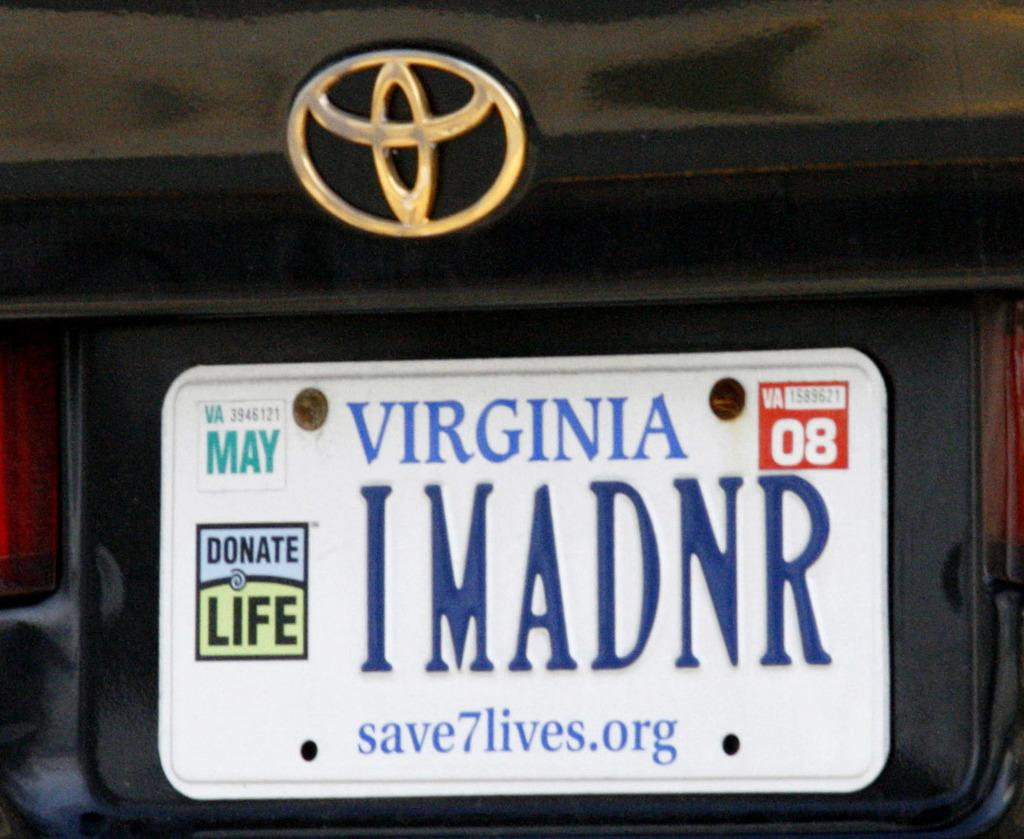What is depicted on the logo in the image? There is a logo of a vehicle in the image. What is attached to the vehicle along with the logo? There is a name plate with numbers and words in the image. How are the logo and name plate connected to the vehicle? The logo and name plate are fixed to the vehicle. What type of book is being read by the driver in the image? There is no driver or book present in the image; it only features a logo and name plate fixed to a vehicle. 